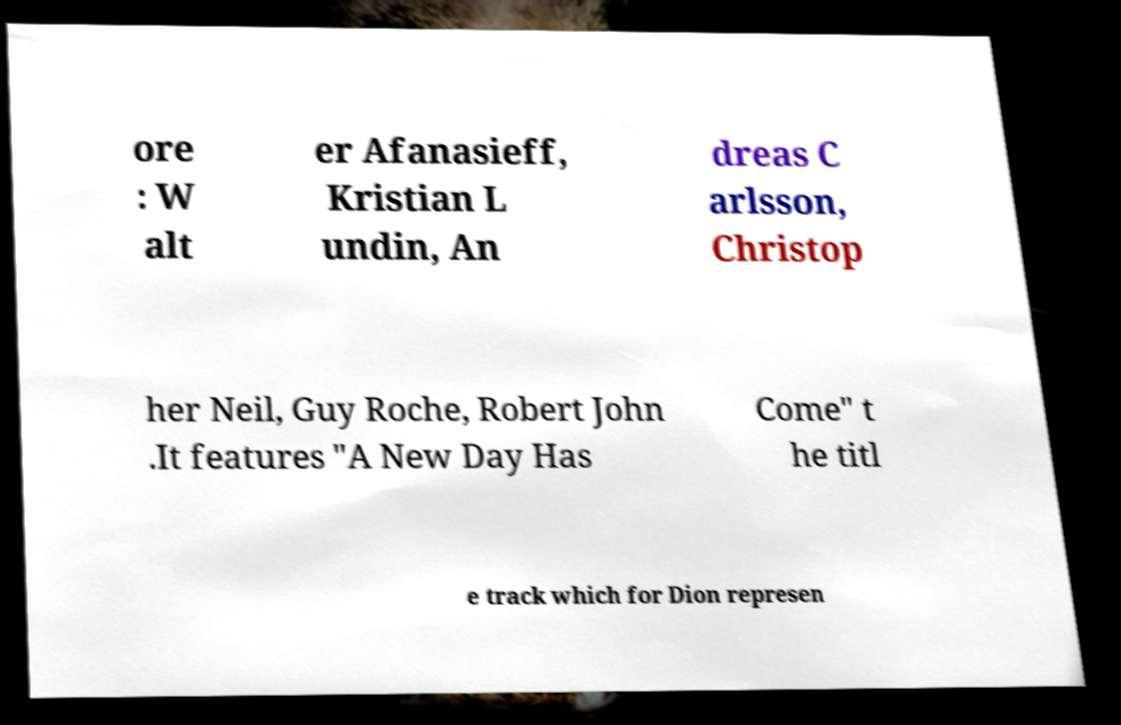Can you read and provide the text displayed in the image?This photo seems to have some interesting text. Can you extract and type it out for me? ore : W alt er Afanasieff, Kristian L undin, An dreas C arlsson, Christop her Neil, Guy Roche, Robert John .It features "A New Day Has Come" t he titl e track which for Dion represen 